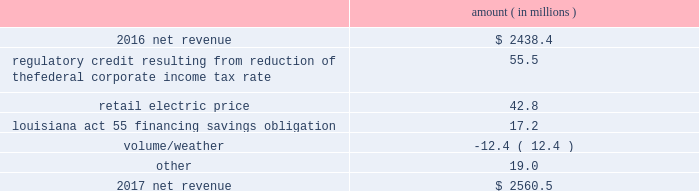Entergy louisiana , llc and subsidiaries management 2019s financial discussion and analysis results of operations net income 2017 compared to 2016 net income decreased $ 305.7 million primarily due to the effect of the enactment of the tax cuts and jobs act , in december 2017 , which resulted in a decrease of $ 182.6 million in net income in 2017 , and the effect of a settlement with the irs related to the 2010-2011 irs audit , which resulted in a $ 136.1 million reduction of income tax expense in 2016 .
Also contributing to the decrease in net income were higher other operation and maintenance expenses .
The decrease was partially offset by higher net revenue and higher other income .
See note 3 to the financial statements for discussion of the effects of the tax cuts and jobs act and the irs audit .
2016 compared to 2015 net income increased $ 175.4 million primarily due to the effect of a settlement with the irs related to the 2010-2011 irs audit , which resulted in a $ 136.1 million reduction of income tax expense in 2016 .
Also contributing to the increase were lower other operation and maintenance expenses , higher net revenue , and higher other income .
The increase was partially offset by higher depreciation and amortization expenses , higher interest expense , and higher nuclear refueling outage expenses .
See note 3 to the financial statements for discussion of the irs audit .
Net revenue 2017 compared to 2016 net revenue consists of operating revenues net of : 1 ) fuel , fuel-related expenses , and gas purchased for resale , 2 ) purchased power expenses , and 3 ) other regulatory charges ( credits ) .
Following is an analysis of the change in net revenue comparing 2017 to 2016 .
Amount ( in millions ) .
The regulatory credit resulting from reduction of the federal corporate income tax rate variance is due to the reduction of the vidalia purchased power agreement regulatory liability by $ 30.5 million and the reduction of the louisiana act 55 financing savings obligation regulatory liabilities by $ 25 million as a result of the enactment of the tax cuts and jobs act , in december 2017 , which lowered the federal corporate income tax rate from 35% ( 35 % ) to 21% ( 21 % ) .
The effects of the tax cuts and jobs act are discussed further in note 3 to the financial statements. .
In 2016 what was the ratio of the increase in the net income to the decrease in tax? 
Computations: (175.4 / 136.1)
Answer: 1.28876. 